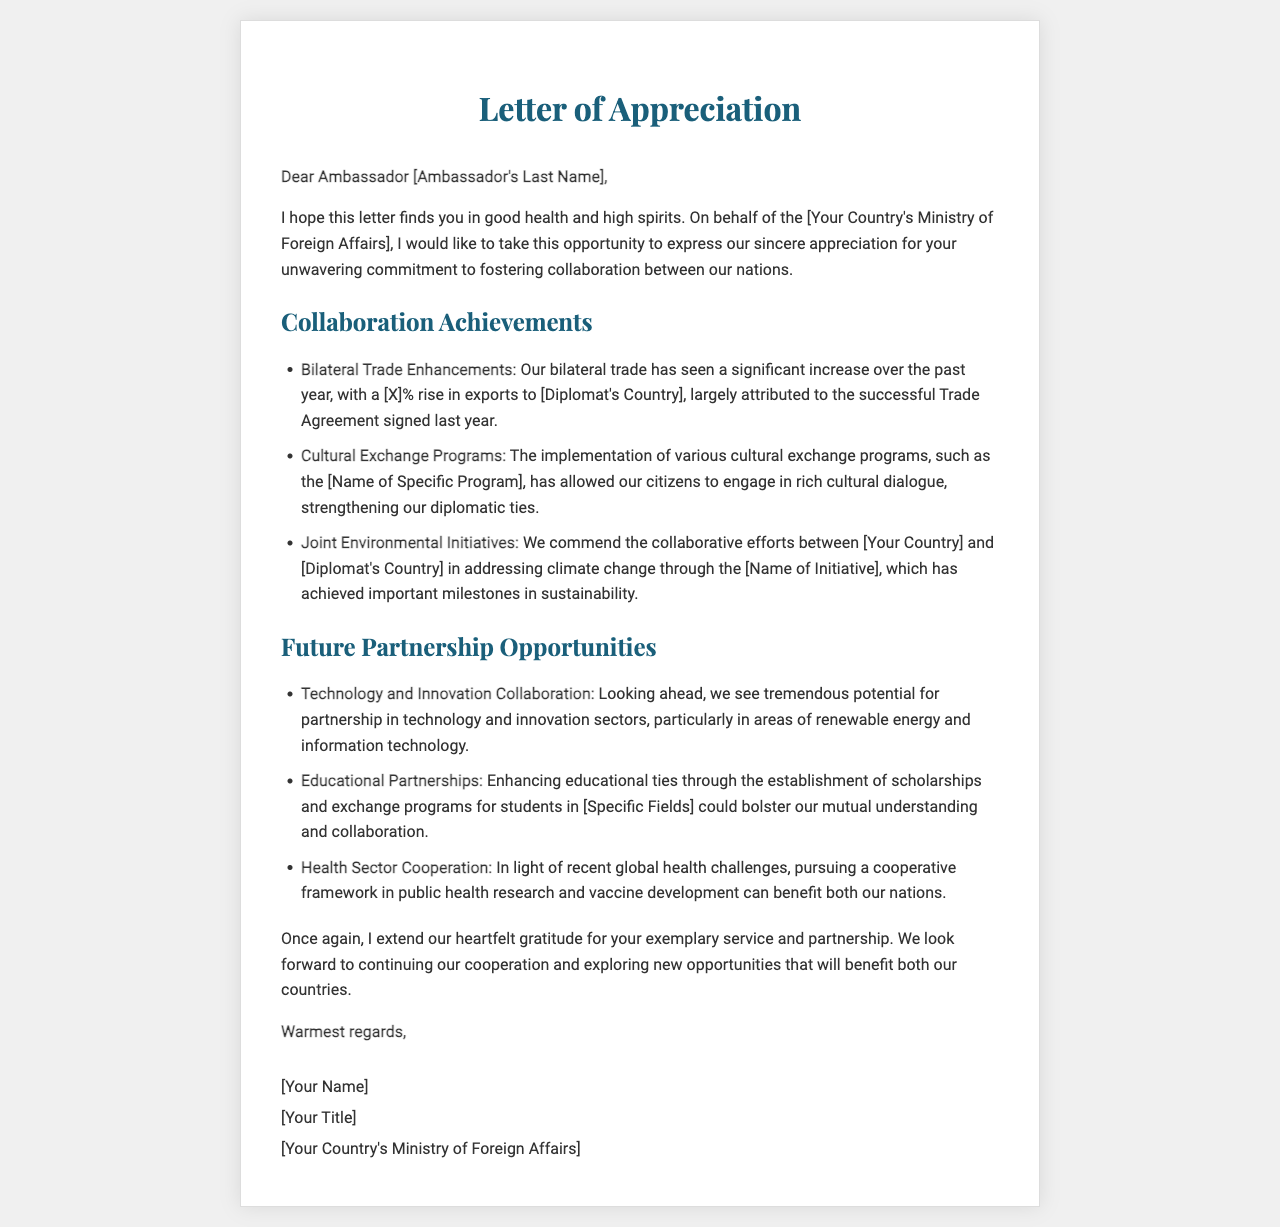What is the main purpose of the letter? The letter expresses appreciation for the diplomat's role in fostering collaboration between the nations.
Answer: Appreciation for collaboration Who is the letter addressed to? The letter is addressed to a specific ambassador, identified as "Ambassador [Ambassador's Last Name]."
Answer: Ambassador [Ambassador's Last Name] What percentage increase is mentioned in relation to bilateral trade? The document states there was a rise in exports to the diplomat's country, specifically mentioning a percentage increase.
Answer: [X]% What is one of the collaborative achievements highlighted in the letter? One of the achievements mentioned in the letter is joint environmental initiatives, specifically the work on climate change.
Answer: Joint environmental initiatives What future opportunity is proposed in the technology sector? The letter proposes collaboration in renewable energy and information technology as future opportunities.
Answer: Renewable energy and information technology Which program is highlighted under cultural exchange programs? The letter references a specific program related to cultural exchange, though the name is not specified in the data provided.
Answer: [Name of Specific Program] What is the closing statement of the letter? The closing of the letter conveys warm regards and expresses gratitude for the partnership.
Answer: Warmest regards What framework is suggested for cooperation in public health? The letter mentions pursuing a cooperative framework in public health research and vaccine development as a future partnership opportunity.
Answer: Cooperative framework in public health research What does the letter commend the ambassador for? The letter commends the ambassador for his exemplary service and partnership in fostering collaboration.
Answer: Exemplary service and partnership 